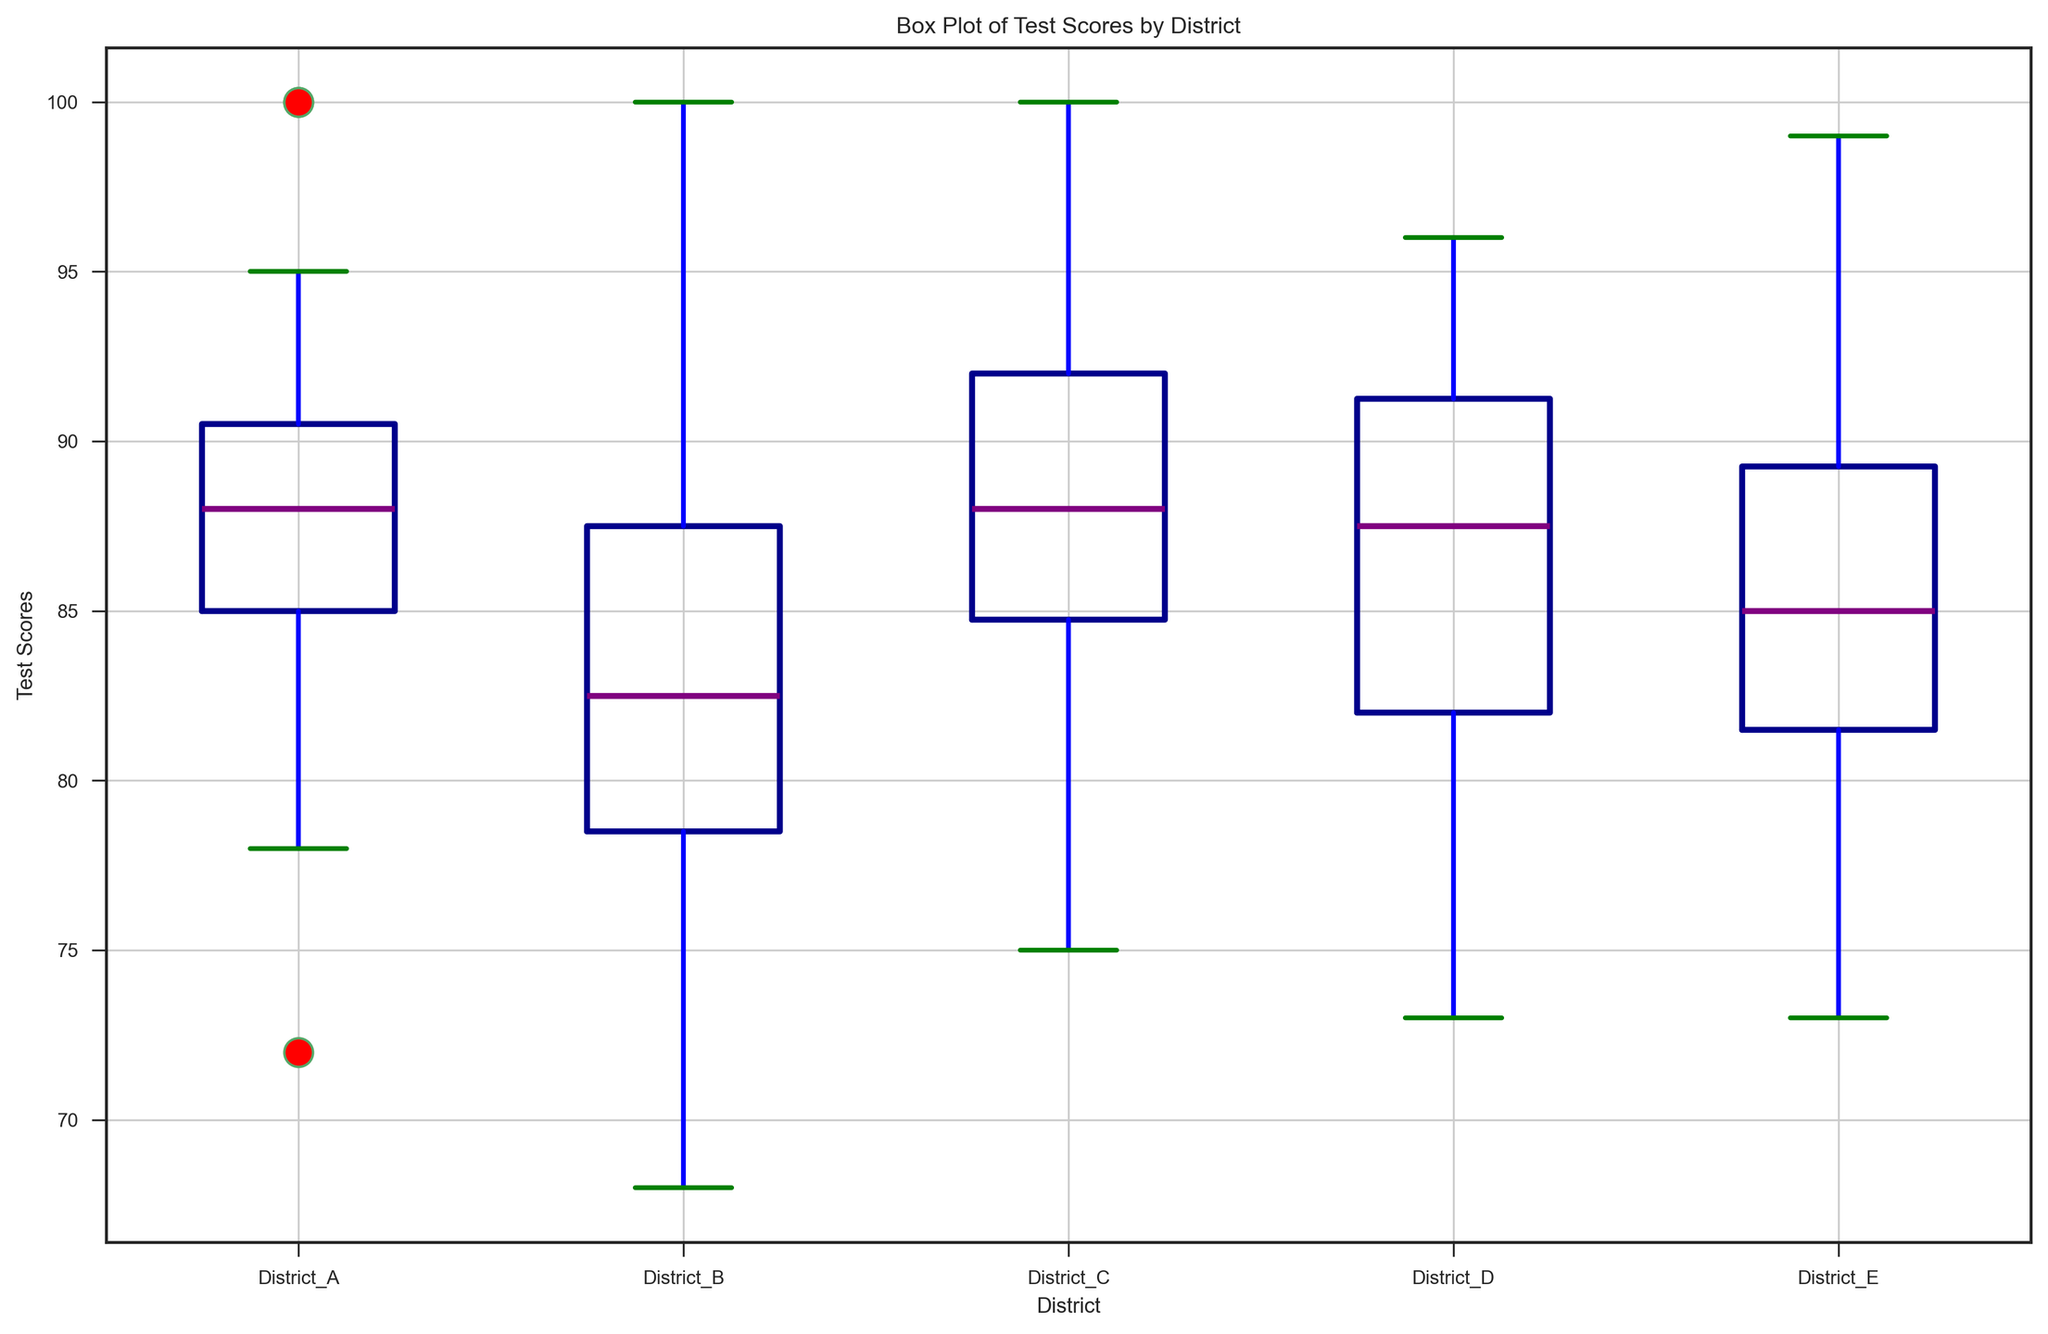What is the highest test score in District A? By looking at the box plot for District A, the highest value is marked as a red dot, which represents the maximum score. In this case, the highest test score in District A is 100.
Answer: 100 Which district has the lowest test scores? To determine the district with the lowest test scores, look for the district whose box plot has the lowest bottom whisker. District B has the lowest bottom whisker, indicating the lowest scores.
Answer: District B What is the median test score in District D? The median test score for District D is indicated by the line within the box of its box plot. For District D, this median line corresponds to a score of approximately 88.
Answer: 88 Which district has the widest interquartile range (IQR) for test scores? The IQR is the range between the first (bottom) and third (top) quartiles, represented by the box length. By observing the length of the boxes, District B has the widest IQR.
Answer: District B Are there any outliers in District E? Outliers are depicted as red dots outside the box plot whiskers. For District E, there is one red dot above the upper whisker, indicating an outlier score of around 99.
Answer: Yes Which district has the highest median test score? The district with the highest median test score has the highest middle line within the box. District C has the highest median at approximately 88.
Answer: District C Is there a district with no outliers? A district with no outliers would not have any red dots outside of its whiskers. Observing the plots, District D has no red dots indicating no outliers.
Answer: Yes How do the medians of Districts A and C compare? Compare the height of the median lines in District A's and District C's box plots. Both have similar medians, very close to each other, around 88.
Answer: They are similar In which district is the range of test scores the narrowest? The range is the difference between the highest and lowest values. District D has the shortest overall height from the bottom to the top-most point, indicating it has the narrowest range.
Answer: District D Which district has the most variability in test scores? The variability can be inferred from the range and IQR. District B, which exhibits a wide IQR and large overall range from minimum to maximum scores, seems to have the most variability.
Answer: District B 